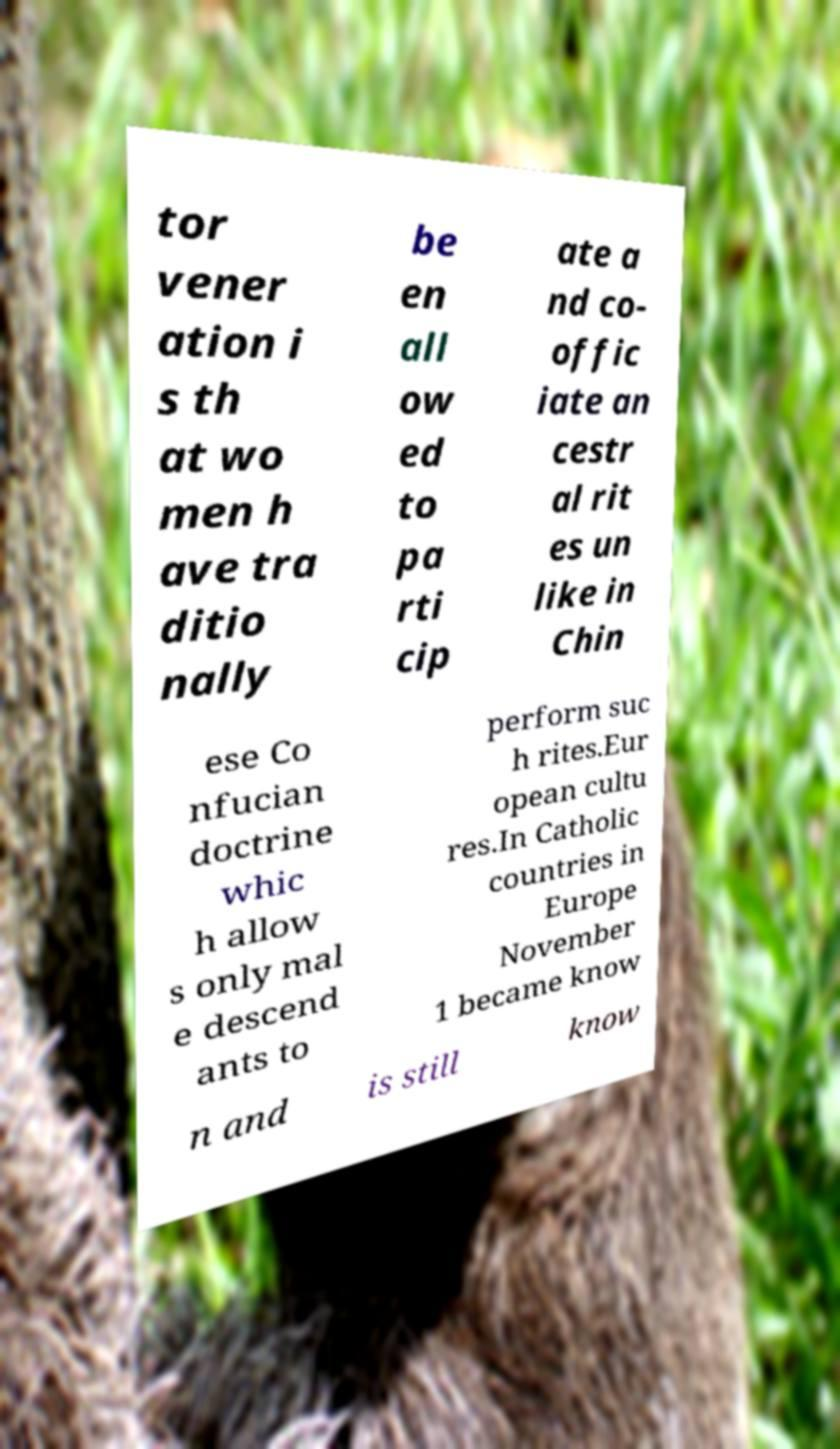Please read and relay the text visible in this image. What does it say? tor vener ation i s th at wo men h ave tra ditio nally be en all ow ed to pa rti cip ate a nd co- offic iate an cestr al rit es un like in Chin ese Co nfucian doctrine whic h allow s only mal e descend ants to perform suc h rites.Eur opean cultu res.In Catholic countries in Europe November 1 became know n and is still know 